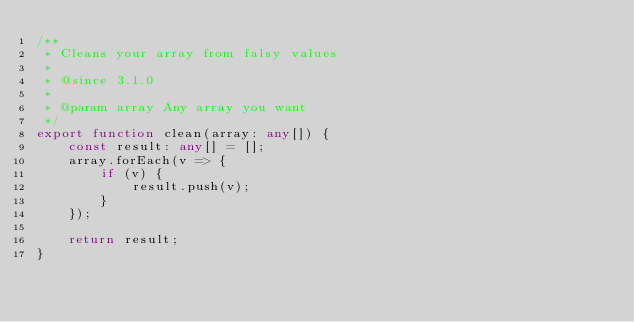<code> <loc_0><loc_0><loc_500><loc_500><_TypeScript_>/**
 * Cleans your array from falsy values
 * 
 * @since 3.1.0
 * 
 * @param array Any array you want
 */
export function clean(array: any[]) {
    const result: any[] = [];
    array.forEach(v => {
        if (v) {
            result.push(v);
        }
    });

    return result;
}</code> 